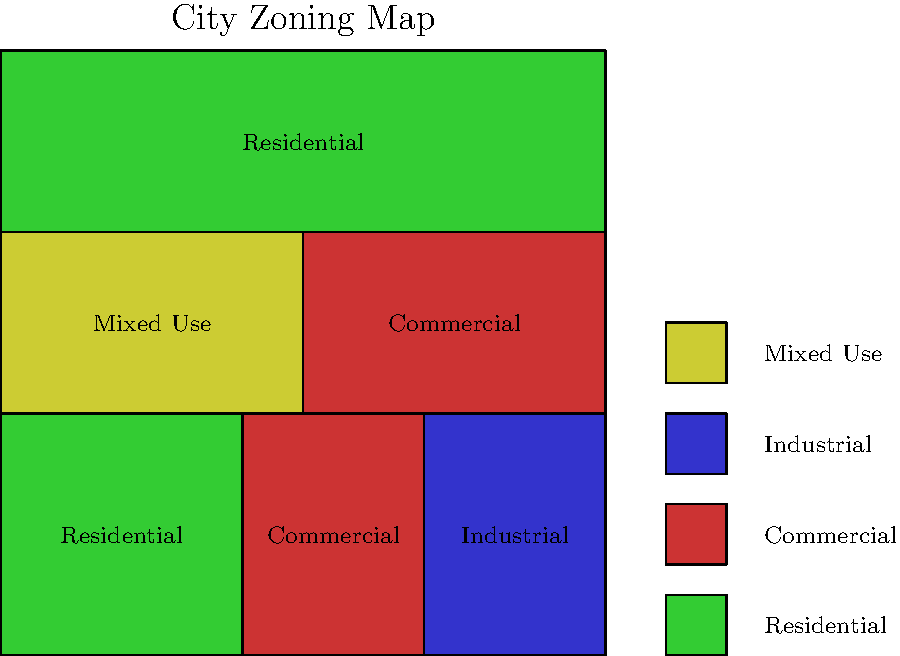Based on the city zoning map provided, what percentage of the total area is zoned for commercial use? Round your answer to the nearest whole number. To determine the percentage of commercial zoning:

1. Divide the map into a 10x10 grid, resulting in 100 equal squares.
2. Count the squares zoned for commercial use:
   - Lower middle section: 3 x 4 = 12 squares
   - Upper right section: 5 x 3 = 15 squares
   - Total commercial squares = 12 + 15 = 27 squares
3. Calculate the percentage:
   $$(27 \text{ squares} / 100 \text{ total squares}) \times 100 = 27\%$$
4. Round to the nearest whole number: 27%

As a commercial property appraiser, understanding zoning distributions is crucial for valuing office buildings, as it affects the supply of available commercial space and potential for future development.
Answer: 27% 